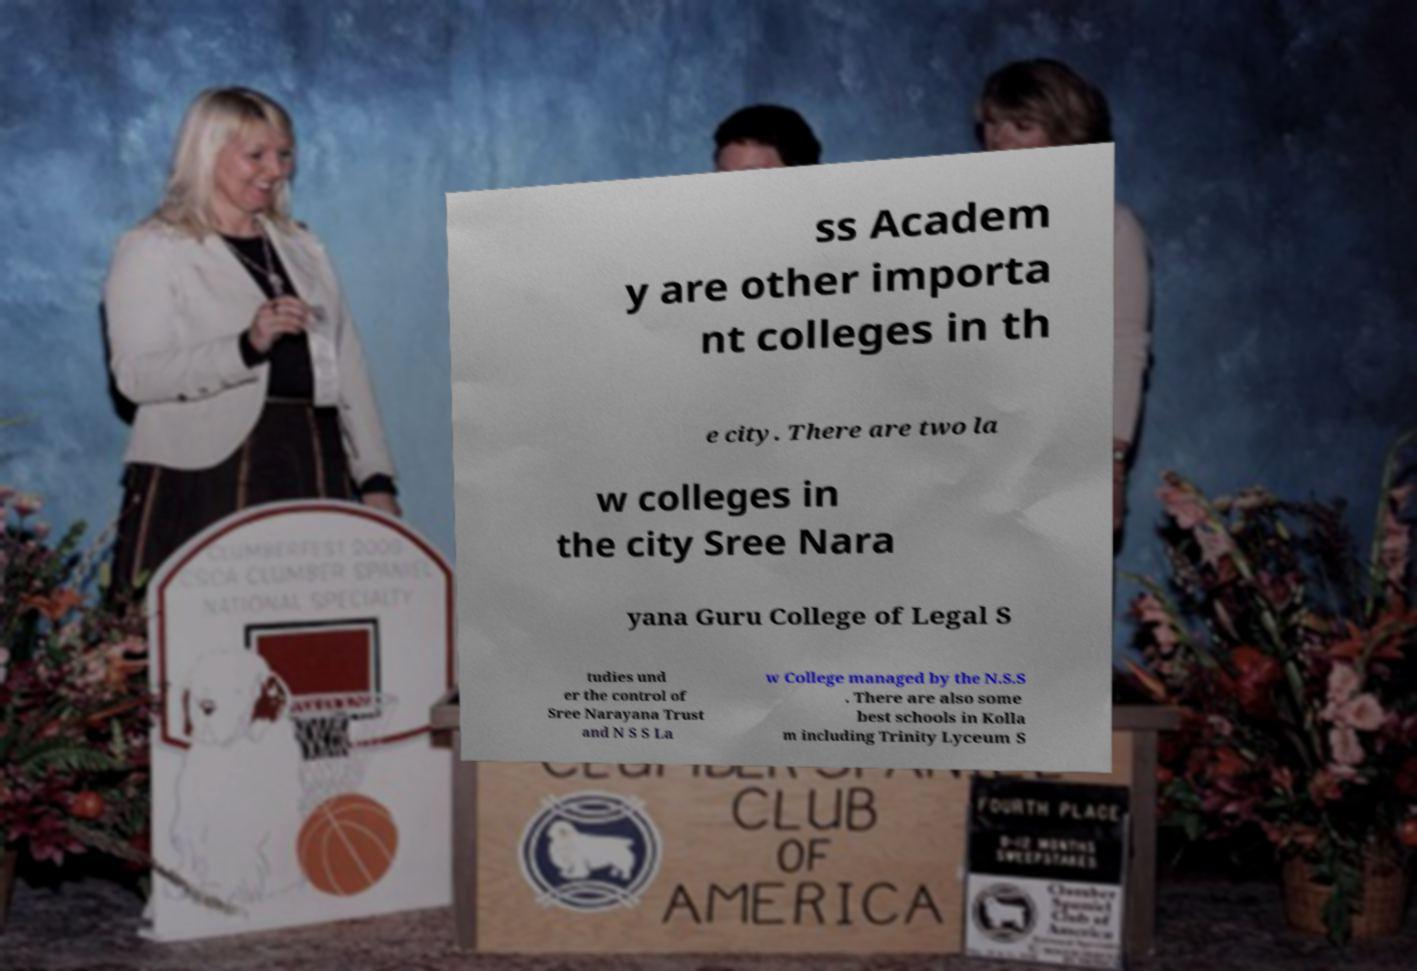There's text embedded in this image that I need extracted. Can you transcribe it verbatim? ss Academ y are other importa nt colleges in th e city. There are two la w colleges in the city Sree Nara yana Guru College of Legal S tudies und er the control of Sree Narayana Trust and N S S La w College managed by the N.S.S . There are also some best schools in Kolla m including Trinity Lyceum S 